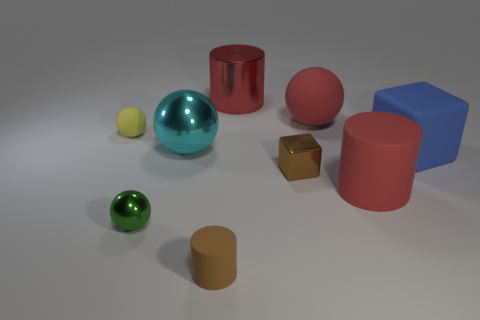How many matte spheres are the same color as the large matte block?
Ensure brevity in your answer.  0. What size is the green sphere in front of the red cylinder in front of the large cylinder to the left of the brown shiny thing?
Offer a very short reply. Small. What number of matte things are big yellow objects or small yellow balls?
Your answer should be compact. 1. There is a blue object; is it the same shape as the tiny rubber thing that is in front of the blue thing?
Provide a succinct answer. No. Are there more red metallic things that are behind the green metal sphere than small green metal balls behind the blue rubber cube?
Provide a short and direct response. Yes. Is there any other thing of the same color as the metal cylinder?
Keep it short and to the point. Yes. There is a brown object that is in front of the big red cylinder that is in front of the blue thing; are there any red objects that are left of it?
Offer a terse response. No. Does the big red thing in front of the yellow ball have the same shape as the green thing?
Provide a short and direct response. No. Is the number of yellow spheres right of the big blue matte thing less than the number of blue cubes left of the green shiny ball?
Your answer should be very brief. No. What is the material of the yellow thing?
Give a very brief answer. Rubber. 